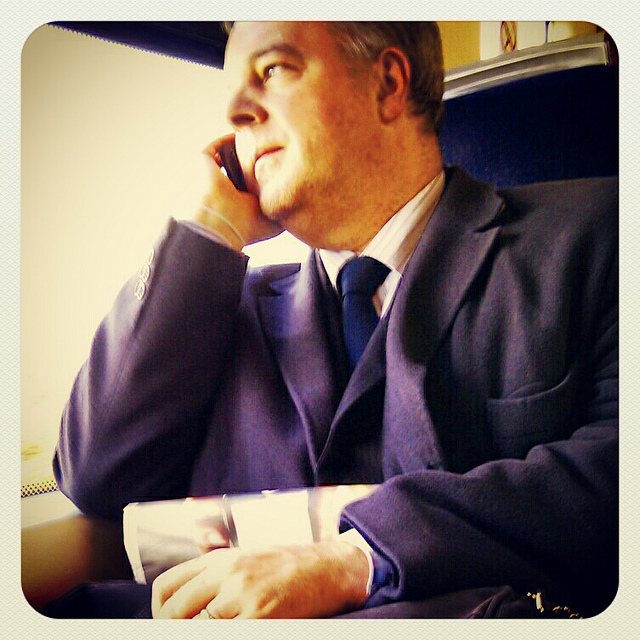How many chairs are on the deck? I'm sorry, there seems to have been a mistake. There is no deck or chairs visible in the image. It features a person who appears to be on a train or similar form of public transportation, speaking on a mobile phone. 